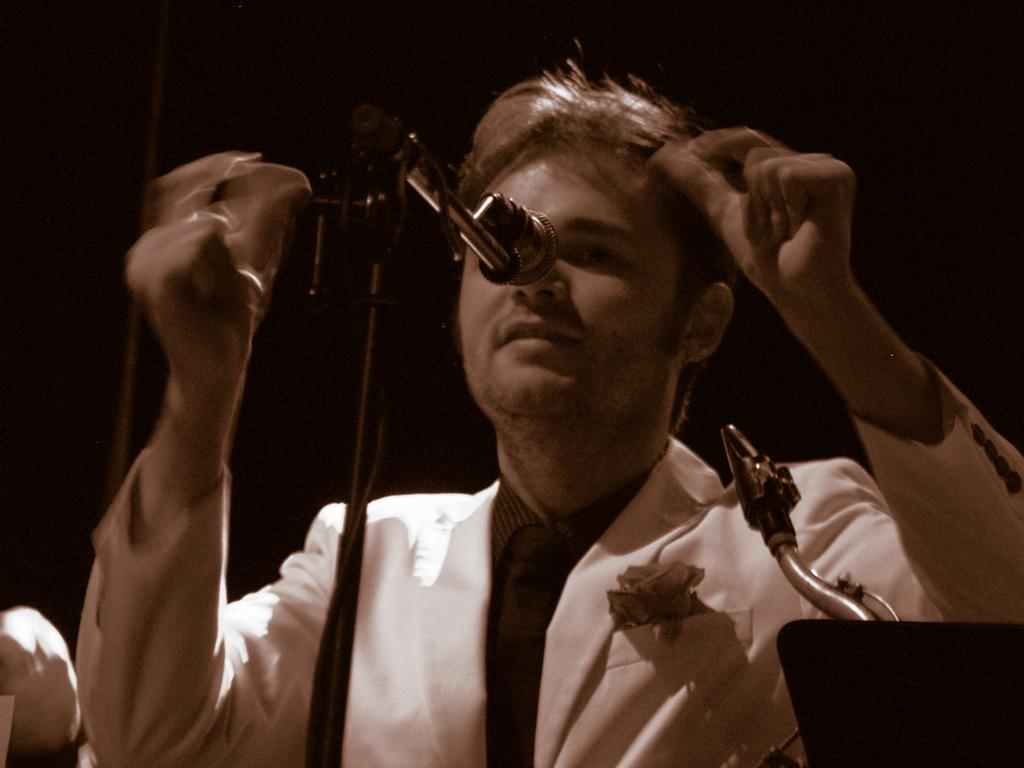Who is the main subject in the image? There is a man in the middle of the image. What is the man doing in the image? The man is in front of a microphone. What can be observed about the background of the image? The background of the image is dark. What decision did the man make before the image was taken? There is no information about any decision made by the man before the image was taken. 